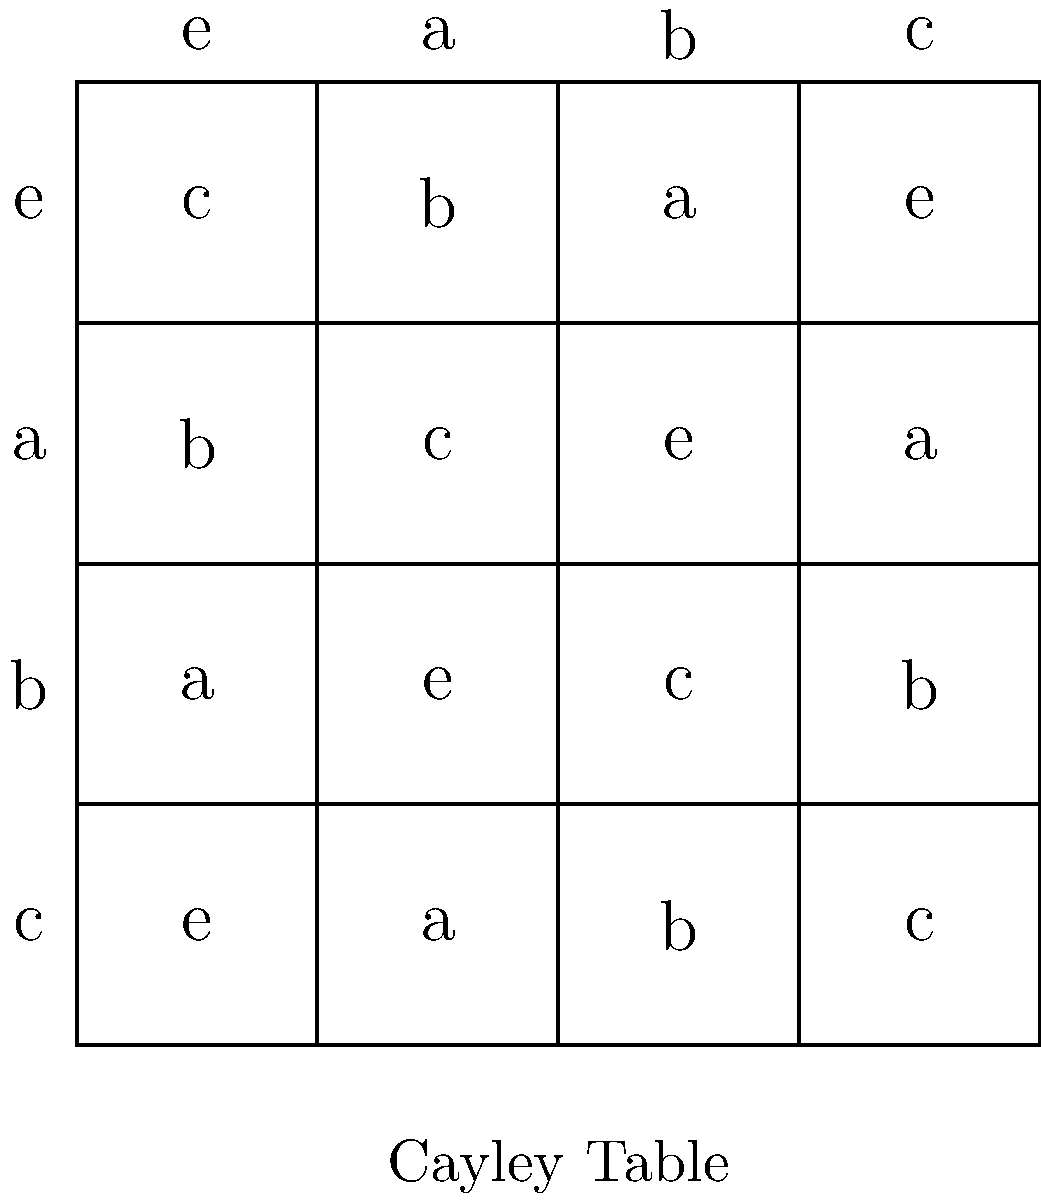As an editor who values first-hand accounts in historical narratives, you encounter a manuscript discussing the development of group theory. The author presents the Cayley table above for a group with four elements: e, a, b, and c. Based on this table, which property of group theory is most clearly illustrated, and how might this relate to the importance of direct observations in historical research? To answer this question, let's analyze the Cayley table step-by-step:

1. Closure: Every cell in the table contains an element of the group, showing that the operation is closed.

2. Associativity: This is assumed in a group but not directly visible from the table.

3. Identity element: The row and column labeled 'e' show that e * x = x * e = x for all x, indicating 'e' is the identity element.

4. Inverse elements: 
   - a * a = e, so a is its own inverse
   - b * c = c * b = e, so b and c are inverses of each other

5. Commutativity: The table is symmetric about the main diagonal, showing that x * y = y * x for all elements. This indicates that this is an abelian group.

The property most clearly illustrated is commutativity, as it's visually apparent from the symmetry of the table.

Relating this to historical research and first-hand accounts:
Just as the Cayley table provides a direct, visual representation of the group's structure, first-hand accounts in historical research offer immediate, unfiltered information about past events. Both allow for direct observation and analysis, minimizing the risk of misinterpretation that can occur with secondary sources or abstract descriptions.

The symmetry in the Cayley table, revealing commutativity, is analogous to corroborating evidence in historical accounts. When multiple first-hand sources align, it strengthens the reliability of the historical narrative, just as the symmetry in the table confirms the commutative property.
Answer: Commutativity, paralleling the value of corroborating first-hand accounts in historical research. 